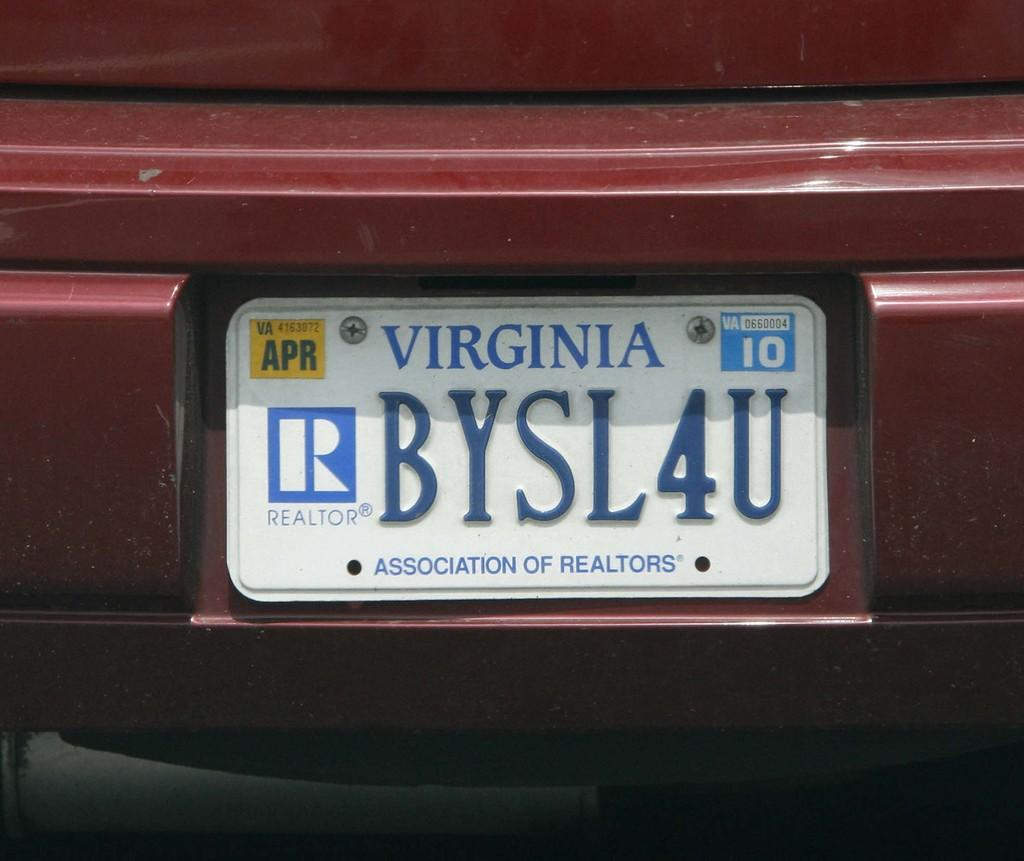<image>
Write a terse but informative summary of the picture. The licence plate of a dark red car registered in Virginia. 